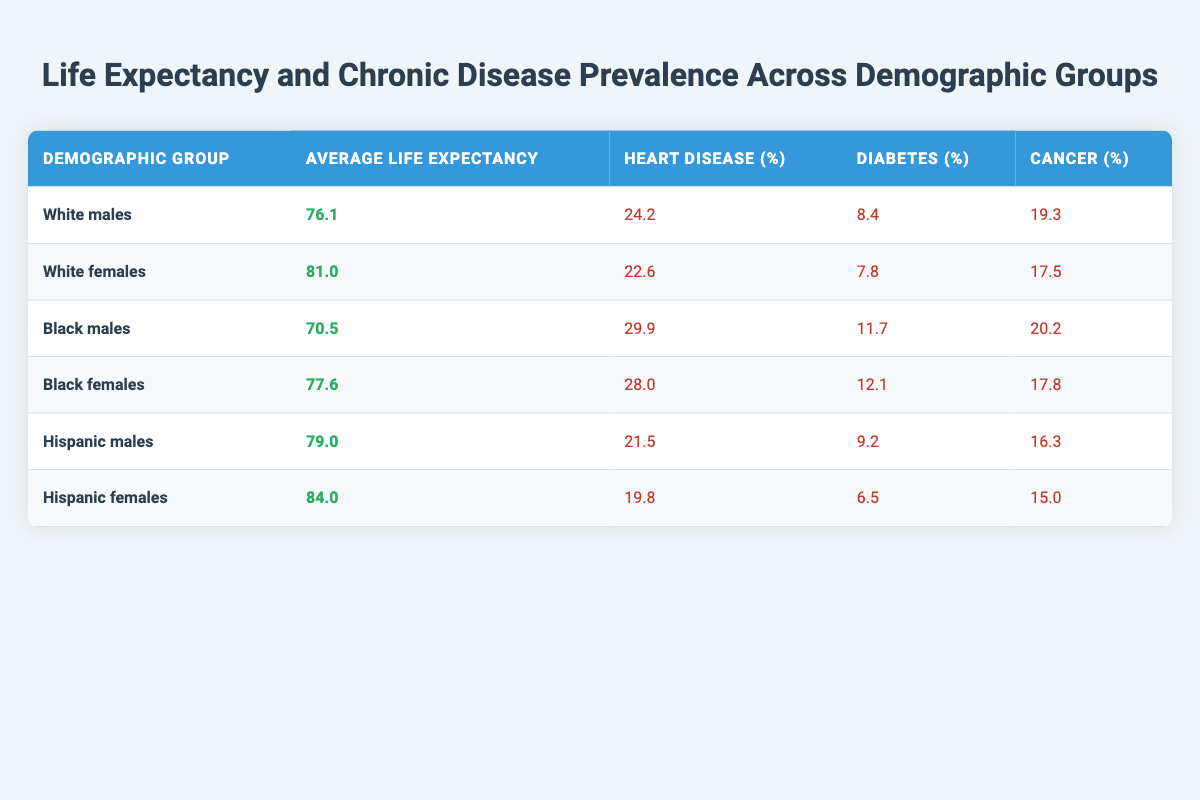What is the average life expectancy for Black females? According to the table, the average life expectancy for Black females is listed directly as 77.6 years.
Answer: 77.6 Which demographic group has the highest prevalence of diabetes? The table shows that Black males have a diabetes prevalence of 11.7%, which is the highest among the groups listed.
Answer: Black males What is the average life expectancy for Hispanic males and females combined? To find the average, we add the life expectancies of Hispanic males (79.0) and Hispanic females (84.0), giving us 163.0. Then, we divide by 2 to get the average: 163.0 / 2 = 81.5.
Answer: 81.5 Is the heart disease prevalence higher for Black males than for Hispanic females? According to the table, Black males have a heart disease prevalence of 29.9%, while Hispanic females have only 19.8%. Therefore, it is true that Black males have a higher prevalence.
Answer: Yes What is the difference in average life expectancy between White females and Black males? The average life expectancy for White females is 81.0 years, and for Black males, it is 70.5 years. The difference is calculated as 81.0 - 70.5 = 10.5 years.
Answer: 10.5 How many demographic groups have an average life expectancy below 80 years? The groups with life expectancies below 80 are White males (76.1), Black males (70.5), and Black females (77.6), totaling three groups.
Answer: 3 Which group has the lowest percentage of cancer prevalence? By examining the cancer percentages in the table, Hispanic females have the lowest prevalence at 15.0%.
Answer: Hispanic females What is the average heart disease prevalence among all groups combined? First, we sum the heart disease prevalence rates: 24.2 + 22.6 + 29.9 + 28.0 + 21.5 + 19.8 = 146.0. Then, divide by 6 (the number of groups) to find the average: 146.0 / 6 = 24.33.
Answer: 24.33 